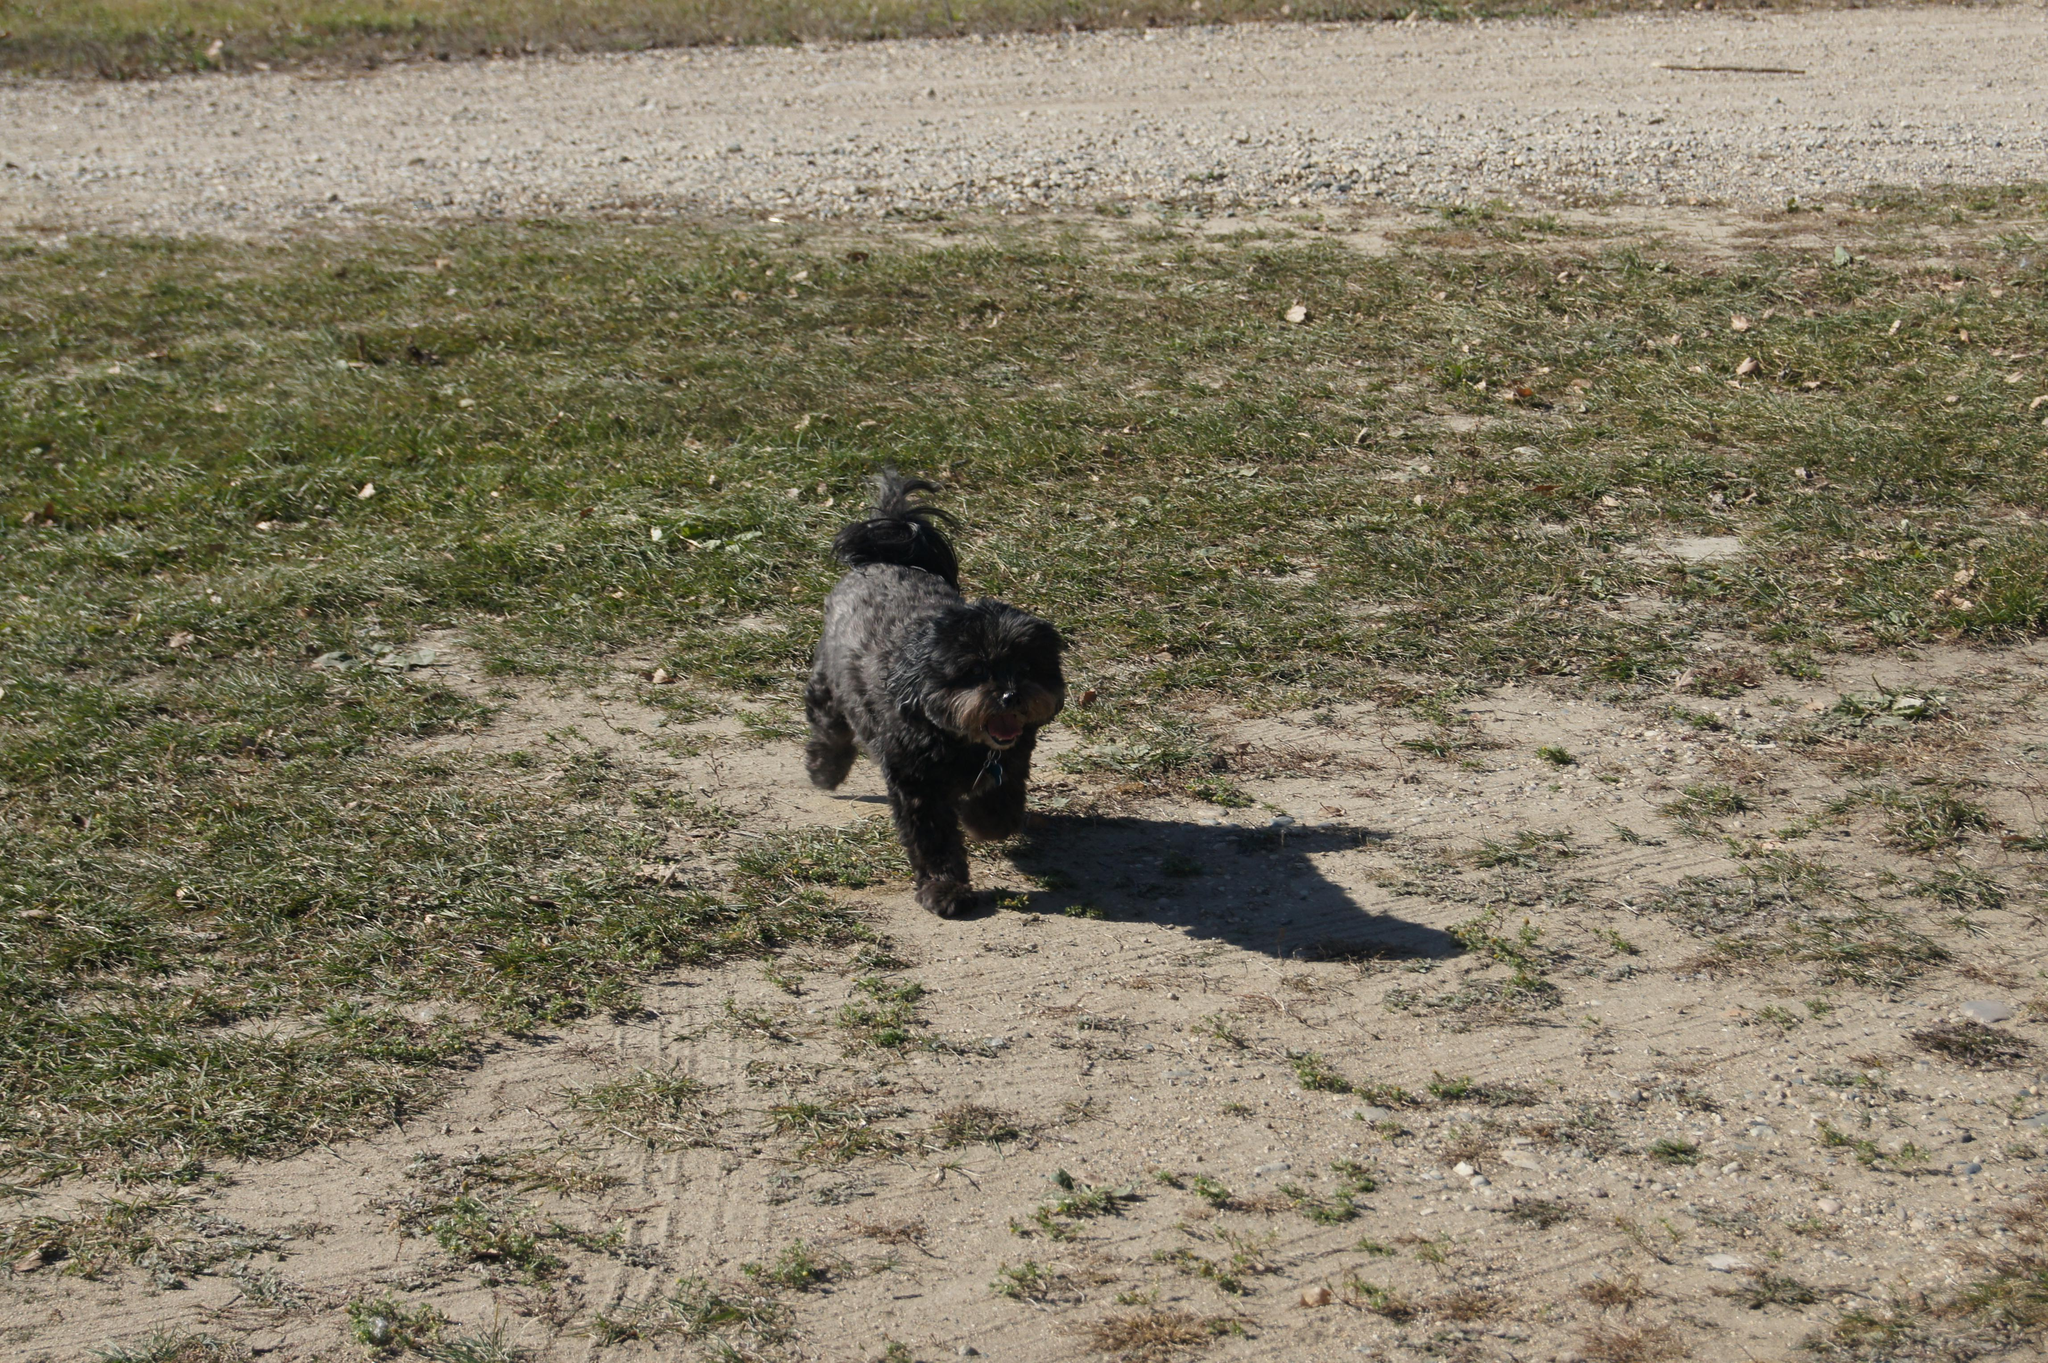What is the main subject in the middle of the picture? There is a black color dog in the middle of the picture. What can be seen in the foreground of the image? In the foreground, there is soil and grass. What is visible in the background of the image? In the background, there are stones, soil, and grass. How many dolls are present in the image? There are no dolls present in the image. Who is the owner of the black color dog in the image? The image does not provide information about the dog's owner. 